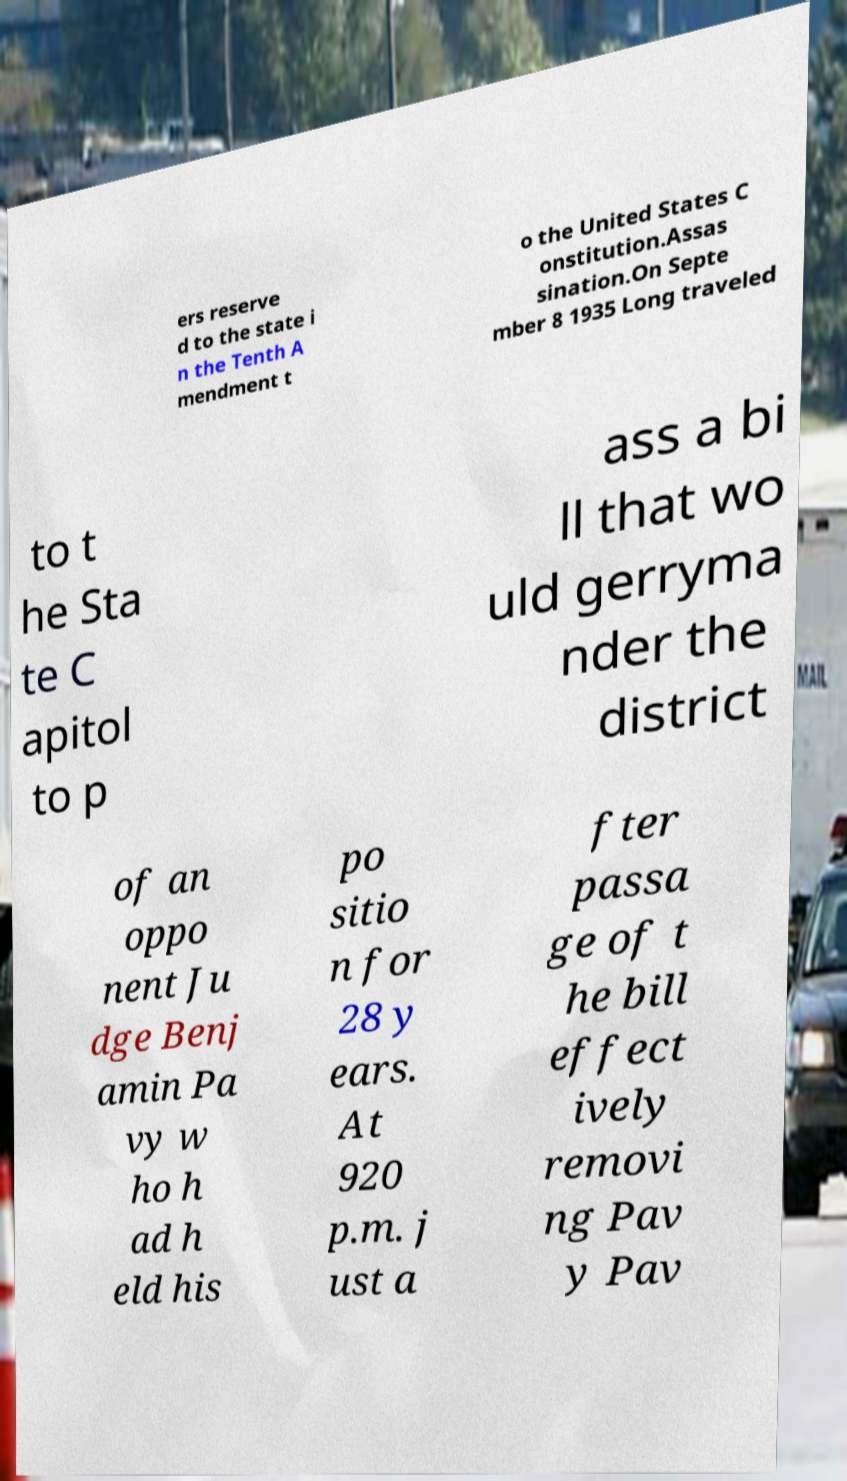Can you read and provide the text displayed in the image?This photo seems to have some interesting text. Can you extract and type it out for me? ers reserve d to the state i n the Tenth A mendment t o the United States C onstitution.Assas sination.On Septe mber 8 1935 Long traveled to t he Sta te C apitol to p ass a bi ll that wo uld gerryma nder the district of an oppo nent Ju dge Benj amin Pa vy w ho h ad h eld his po sitio n for 28 y ears. At 920 p.m. j ust a fter passa ge of t he bill effect ively removi ng Pav y Pav 